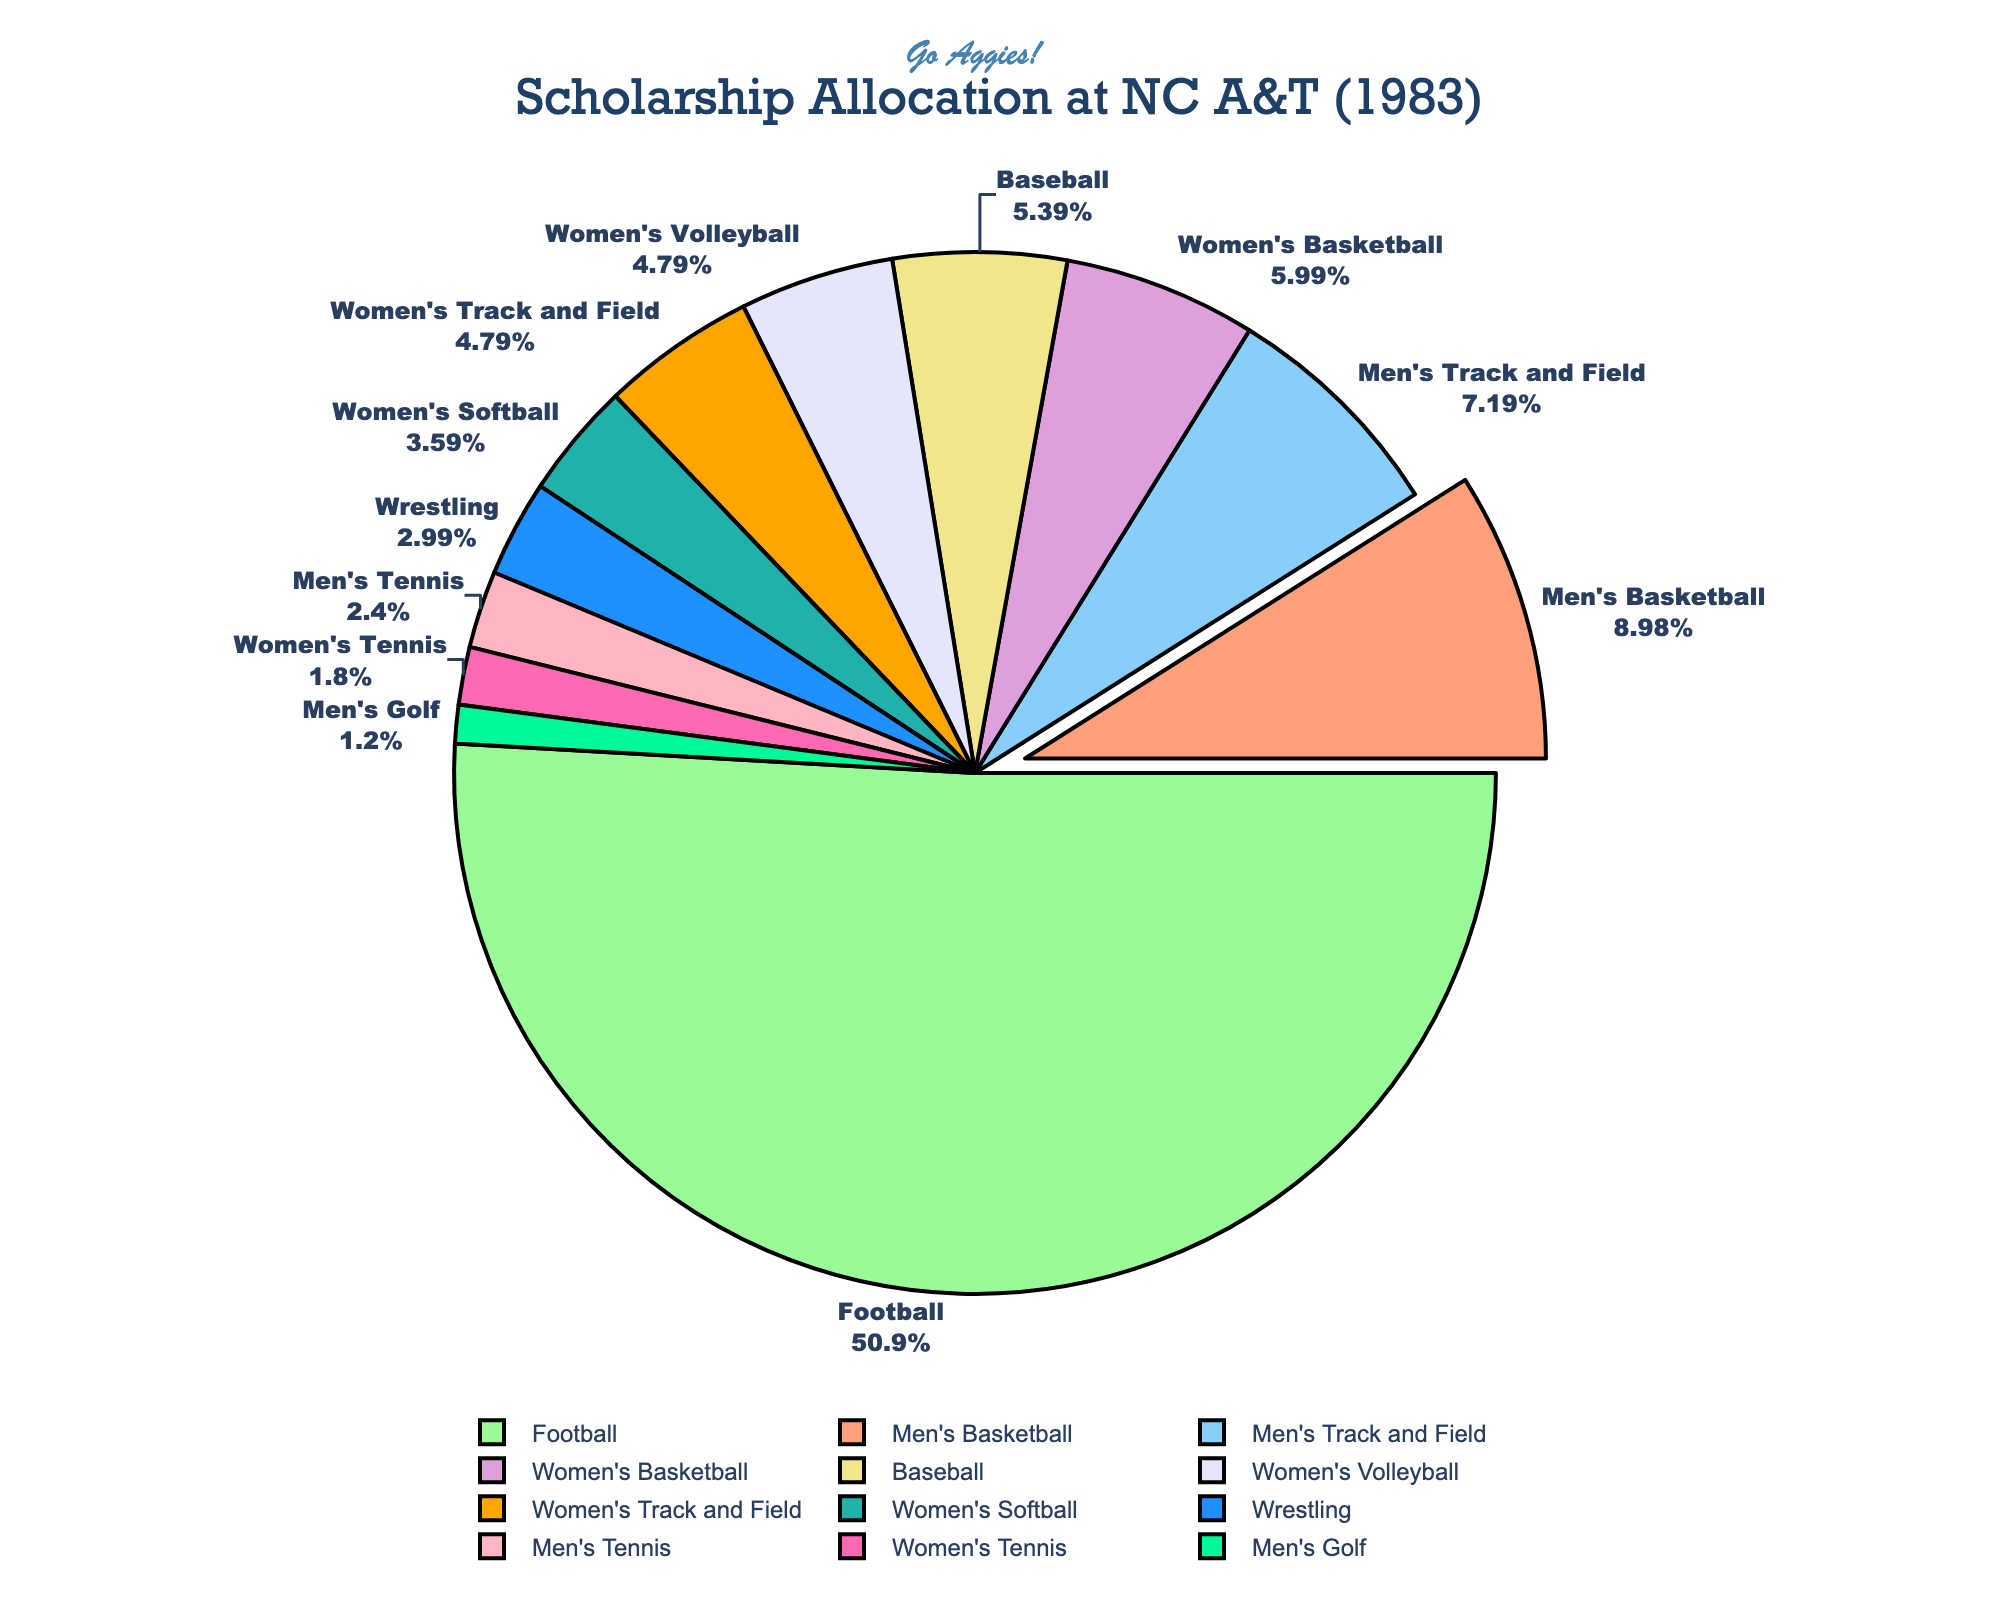Which sport received the most scholarships? By looking at the pie chart, identify the sport with the largest slice in the chart. The largest slice represents the sport with the most scholarships.
Answer: Football Which sport received the second most scholarships? After identifying the sport with the largest slice, look for the next largest slice in the pie chart to determine which sport received the second most scholarships.
Answer: Men's Basketball Which three sports combined account for the majority of scholarships? Identify the three sports with the largest slices in the pie chart and sum their scholarship counts. Largest slices are for Football, Men's Basketball, and Men's Track and Field.
Answer: Football, Men's Basketball, Men's Track and Field How many more scholarships did Football receive compared to Men's Basketball? First, find the scholarship count for Football (85) and Men's Basketball (15). Then subtract the Men's Basketball count from the Football count: 85 - 15.
Answer: 70 What percentage of the total scholarships was allocated to Women's sports? Sum the scholarships for Women's Basketball (10), Women's Volleyball (8), Women's Softball (6), Women's Track and Field (8), and Women's Tennis (3): 10 + 8 + 6 + 8 + 3 = 35. Then, divide by the total number of scholarships (177) and multiply by 100 to get the percentage: 35/177 * 100.
Answer: 19.8% Which sport receiving 5 scholarships in the pie chart? Look at the pie chart and find the slice labeled with a scholarship count of 5.
Answer: Wrestling If scholarships were allocated equally among Men's Basketball and Women's Basketball, what would be the new value for each? Add the scholarships for Men's Basketball (15) and Women's Basketball (10), then divide by 2: (15 + 10) / 2.
Answer: 12.5 Which sport had the smallest allocation of scholarships? Identify the smallest slice in the pie chart, which represents the sport with the fewest scholarships.
Answer: Men's Golf 